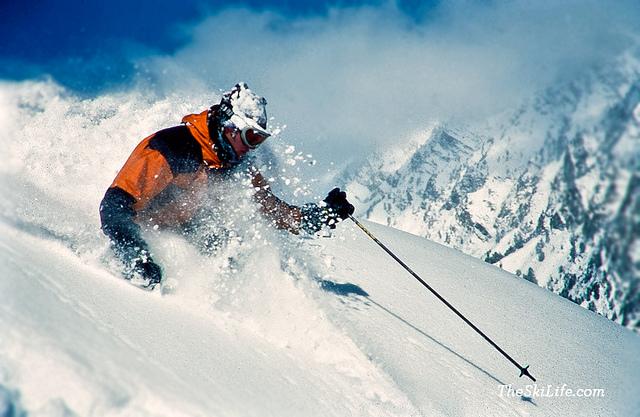Does this image appear to have been captured by a professional photographer?
Answer briefly. Yes. Is it cold?
Answer briefly. Yes. Is the person skiing?
Quick response, please. Yes. 